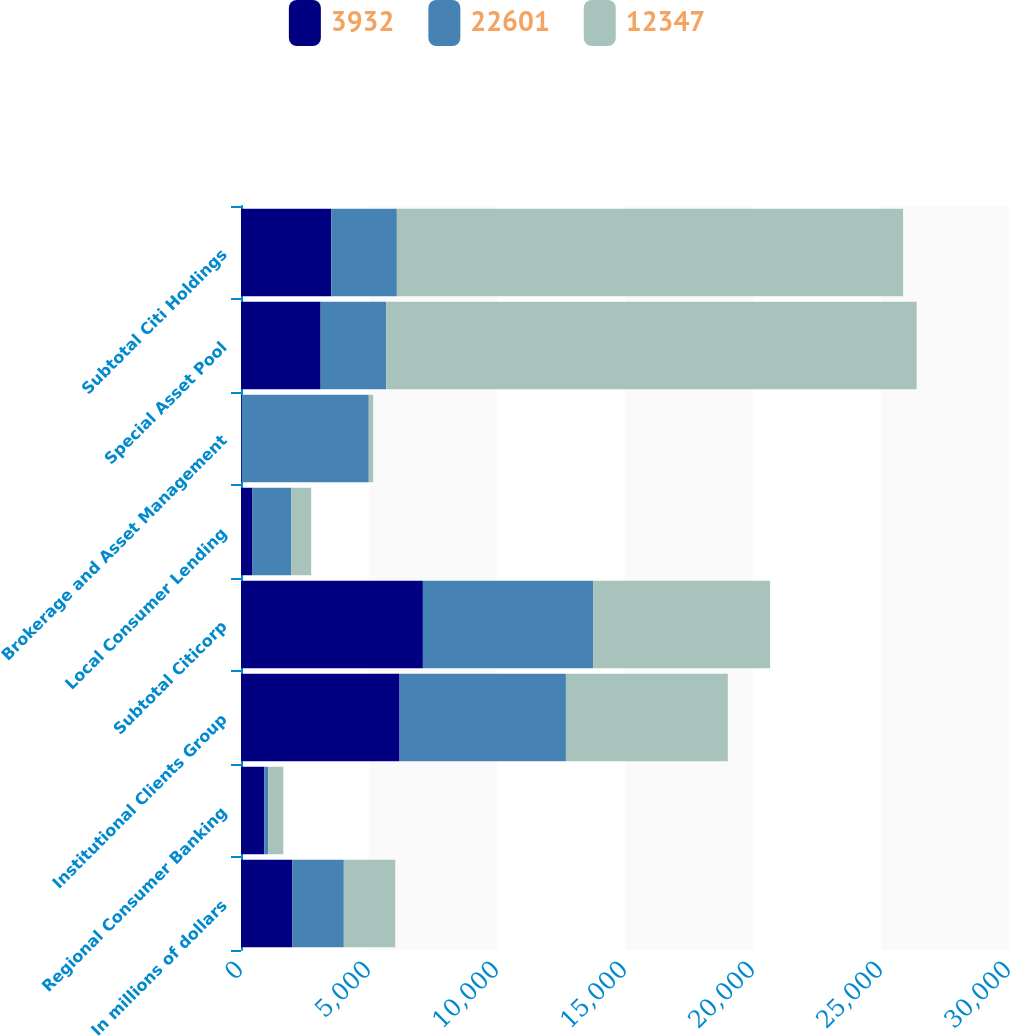<chart> <loc_0><loc_0><loc_500><loc_500><stacked_bar_chart><ecel><fcel>In millions of dollars<fcel>Regional Consumer Banking<fcel>Institutional Clients Group<fcel>Subtotal Citicorp<fcel>Local Consumer Lending<fcel>Brokerage and Asset Management<fcel>Special Asset Pool<fcel>Subtotal Citi Holdings<nl><fcel>3932<fcel>2009<fcel>911<fcel>6194<fcel>7105<fcel>449<fcel>33<fcel>3112<fcel>3528<nl><fcel>22601<fcel>2008<fcel>149<fcel>6498<fcel>6647<fcel>1520<fcel>4958<fcel>2560.5<fcel>2560.5<nl><fcel>12347<fcel>2007<fcel>592<fcel>6324<fcel>6916<fcel>773<fcel>172<fcel>20719<fcel>19774<nl></chart> 